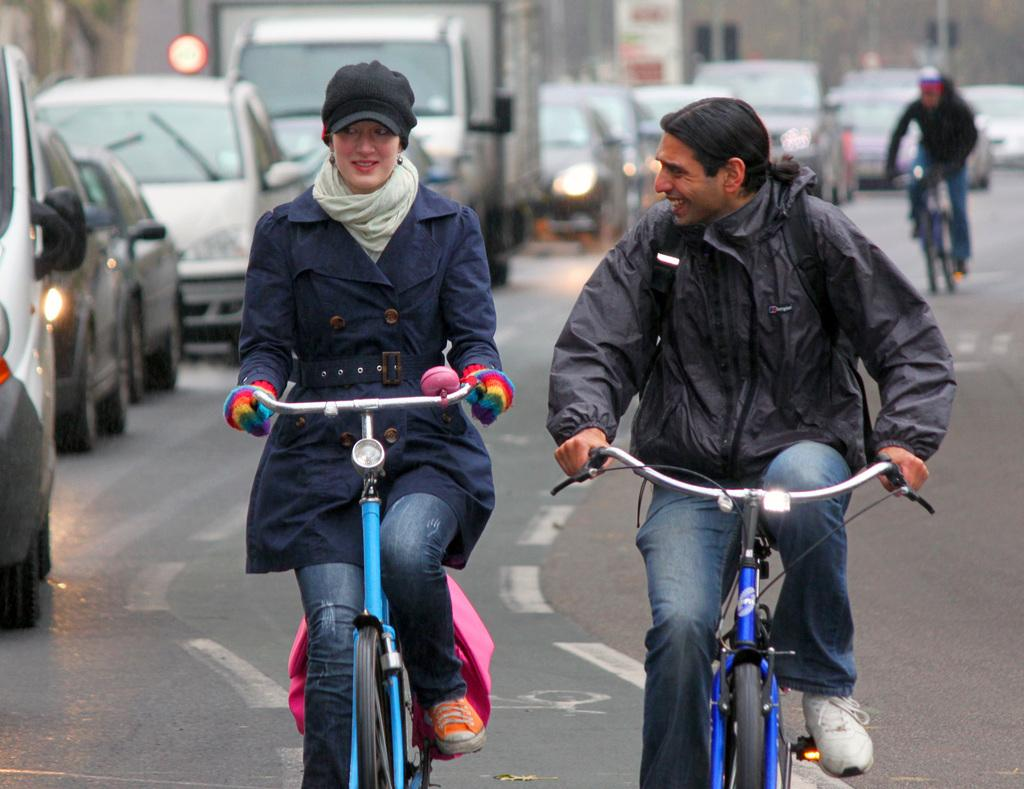What are the people in the image doing? The people in the image are riding bicycles. How many people are riding bicycles in the image? There are three people riding bicycles in the image. What else can be seen on the road in the image? There are parked cars on the road in the image. What type of drawer can be seen in the image? There is no drawer present in the image; it features people riding bicycles and parked cars on the road. How does the person riding the bicycle in front of them hear the conversation? The image does not provide information about any conversation or hearing ability of the people in the image. 